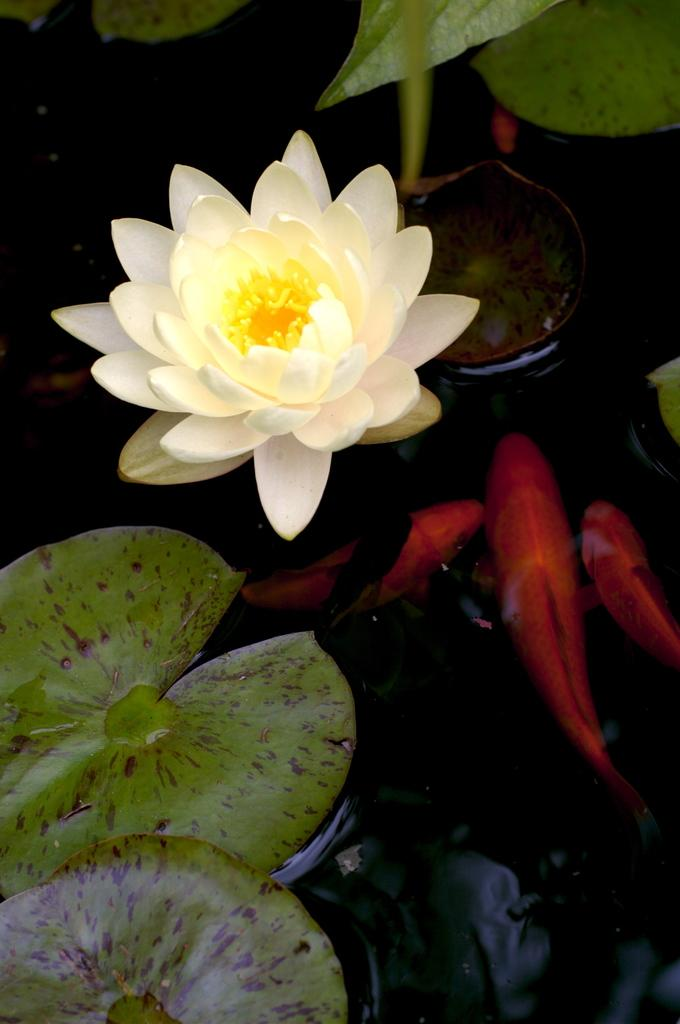What is floating on the water in the image? There are leaves on the water in the image. What can be seen in the middle of the image? There is a lotus in the middle of the image. How many clocks can be seen hanging on the lotus in the image? There are no clocks present in the image, and the lotus is not depicted as having any hanging objects. 